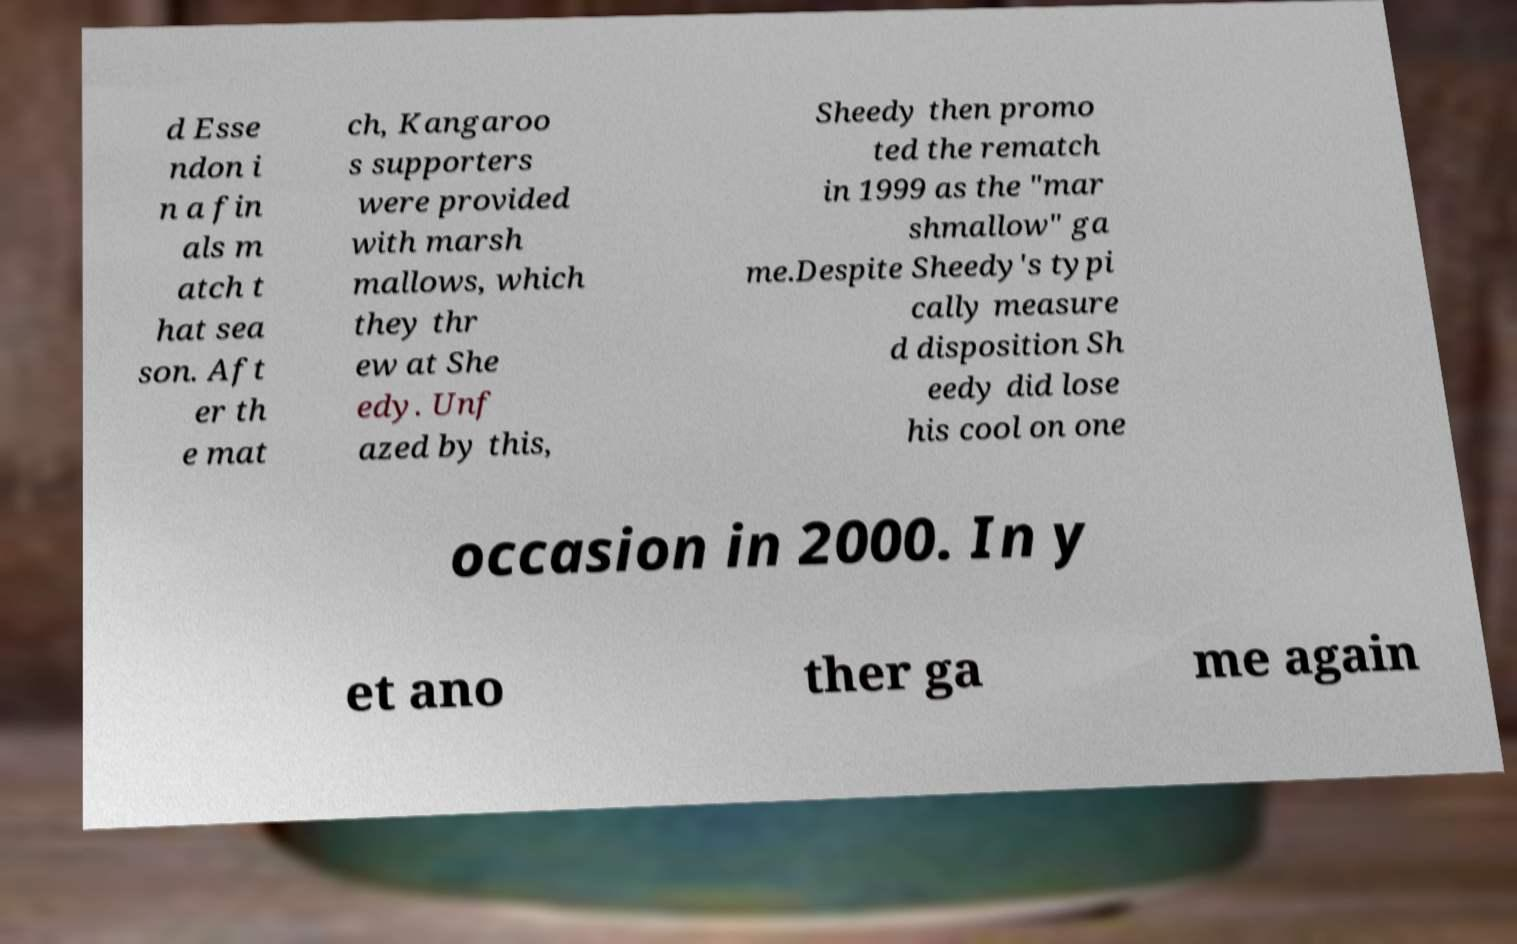Please read and relay the text visible in this image. What does it say? d Esse ndon i n a fin als m atch t hat sea son. Aft er th e mat ch, Kangaroo s supporters were provided with marsh mallows, which they thr ew at She edy. Unf azed by this, Sheedy then promo ted the rematch in 1999 as the "mar shmallow" ga me.Despite Sheedy's typi cally measure d disposition Sh eedy did lose his cool on one occasion in 2000. In y et ano ther ga me again 